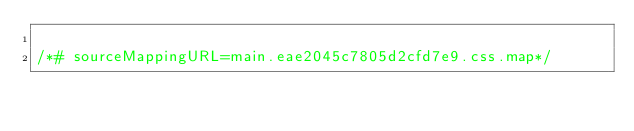Convert code to text. <code><loc_0><loc_0><loc_500><loc_500><_CSS_>
/*# sourceMappingURL=main.eae2045c7805d2cfd7e9.css.map*/</code> 